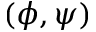<formula> <loc_0><loc_0><loc_500><loc_500>( \phi , \psi )</formula> 